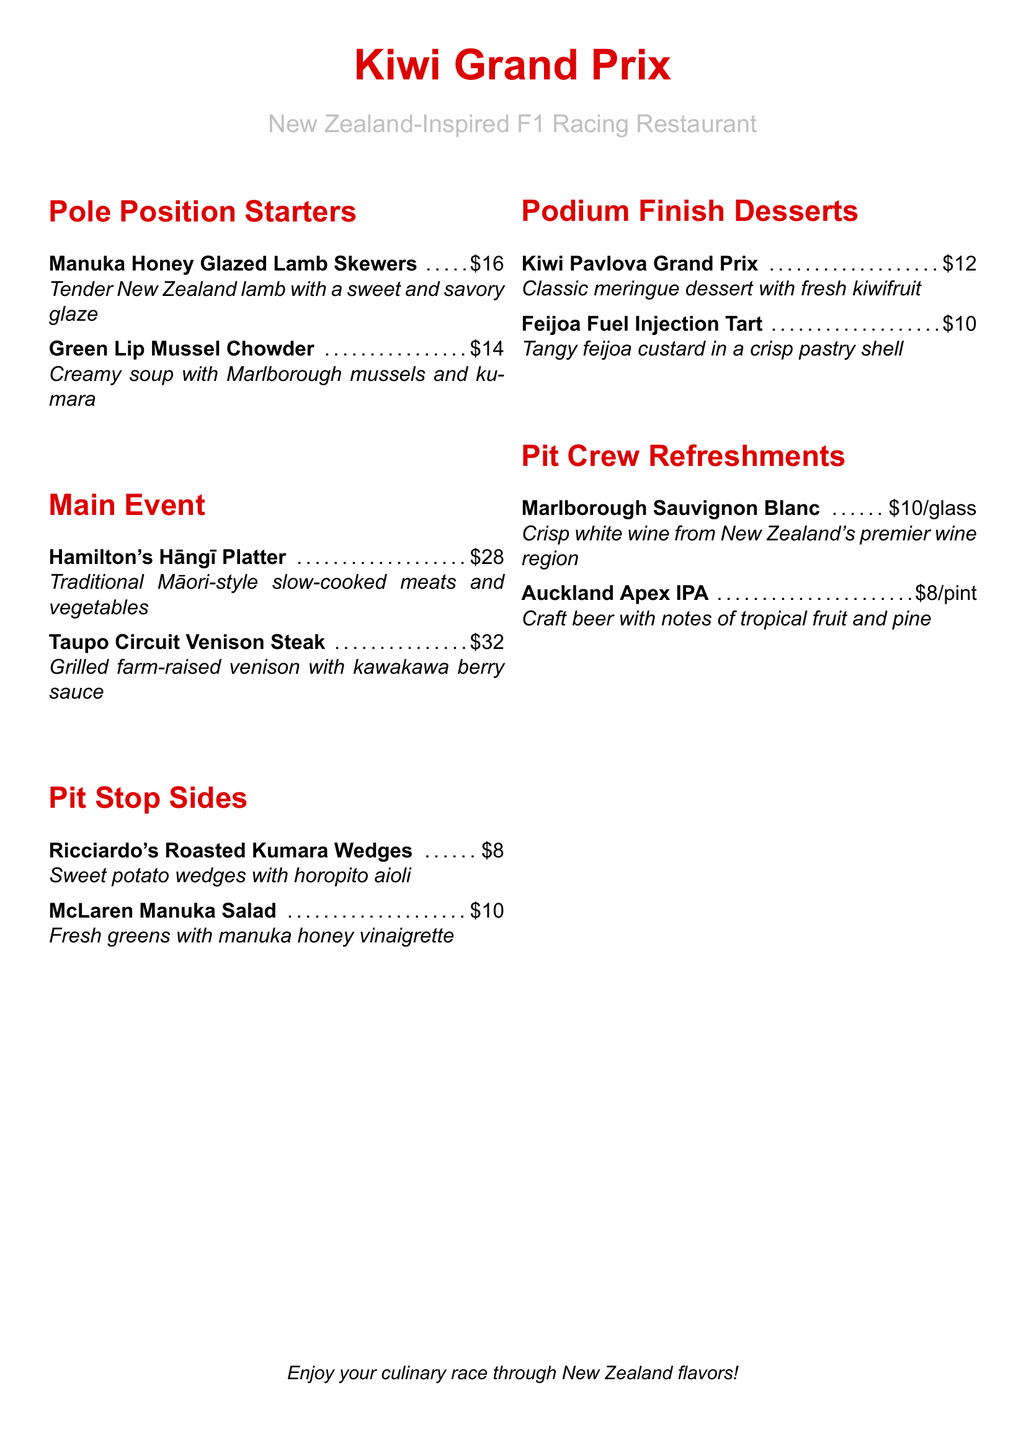What is the name of the restaurant? The restaurant name is presented at the top of the menu.
Answer: Kiwi Grand Prix What is the price of the Green Lip Mussel Chowder? The price for this dish can be found in the menu section.
Answer: $14 What is the main ingredient in Hamilton's Hāngī Platter? This dish is described as a traditional Māori-style meal, indicating it includes slow-cooked meats and vegetables.
Answer: meats and vegetables Which dish features sweet potatoes? The menu indicates which side dish includes sweet potatoes.
Answer: Ricciardo's Roasted Kumara Wedges How much does a glass of Marlborough Sauvignon Blanc cost? The price for this refreshment can be found in the designated section of the menu.
Answer: $10/glass What is the theme of the restaurant? The title and introduction provide insights into the restaurant's overall concept.
Answer: New Zealand-Inspired F1 Racing Which dessert includes kiwifruit? The menu specifically lists one dessert that includes kiwifruit in its name.
Answer: Kiwi Pavlova Grand Prix What type of beer is featured on this menu? The specific beer name and attributes are listed under refreshments.
Answer: Auckland Apex IPA What is the total number of sections in the menu? By counting the sections as laid out in the menu, we can determine this total.
Answer: 5 